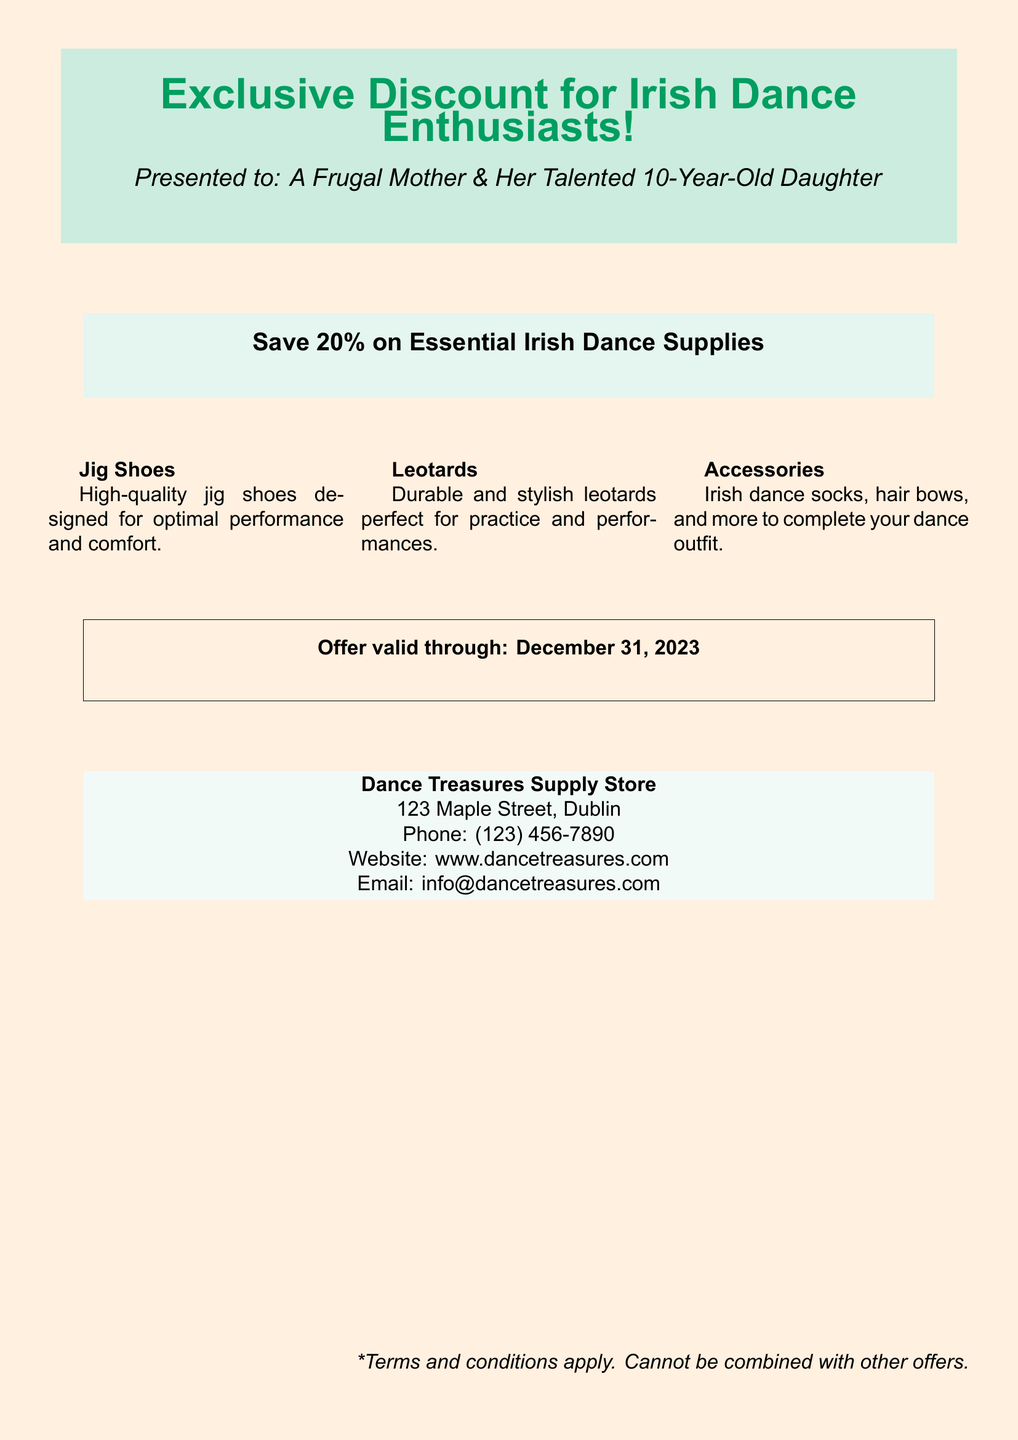what is the discount percentage offered? The document states a 20% discount on essential Irish dance supplies.
Answer: 20% who is the voucher presented to? The voucher is presented to "A Frugal Mother & Her Talented 10-Year-Old Daughter."
Answer: A Frugal Mother & Her Talented 10-Year-Old Daughter what is the expiration date of the offer? The offer is valid through December 31, 2023, as indicated in the document.
Answer: December 31, 2023 what types of items are included in the discount? The document lists jig shoes, leotards, and accessories as the types of items included.
Answer: jig shoes, leotards, and accessories what is the name of the store offering the discount? The store offering the discount is called "Dance Treasures Supply Store."
Answer: Dance Treasures Supply Store where is the store located? The document provides the address of the store as 123 Maple Street, Dublin.
Answer: 123 Maple Street, Dublin what is the phone number of the store? The document lists the phone number as (123) 456-7890.
Answer: (123) 456-7890 what format does the document use for the discount information? The document uses a promotional format to present the discount information prominently.
Answer: promotional format 